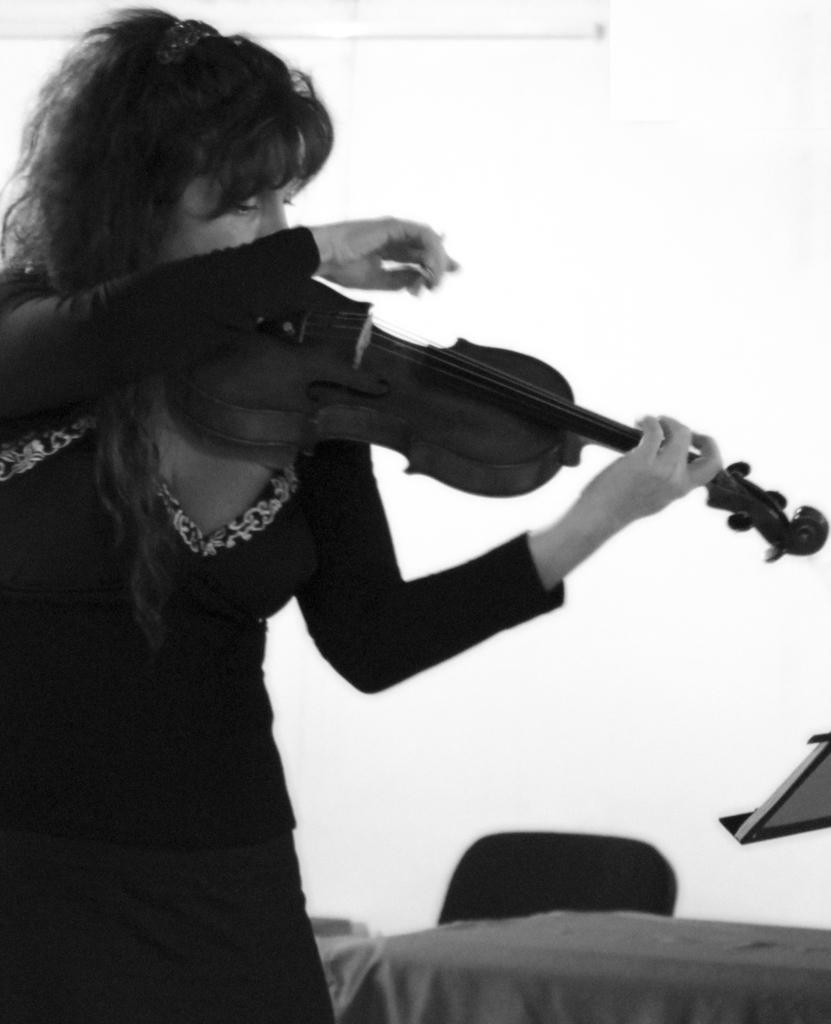What is the main subject of the image? There is a person in the image. What is the person holding in the image? The person is holding a guitar. What type of pen is the person using to write on the board in the image? There is no pen or board present in the image; the person is holding a guitar. How does the person's cough affect the sound of the guitar in the image? There is no cough or indication of a cough in the image; the person is simply holding a guitar. 